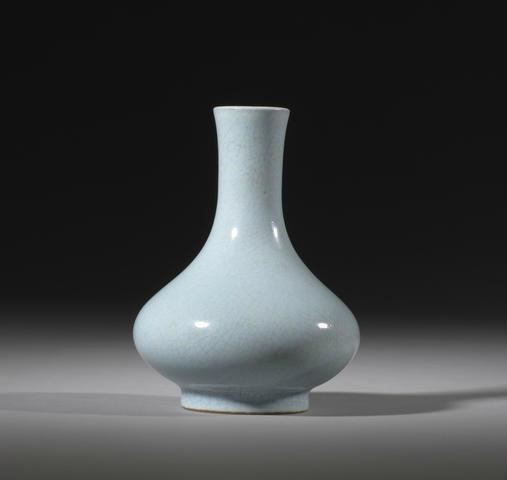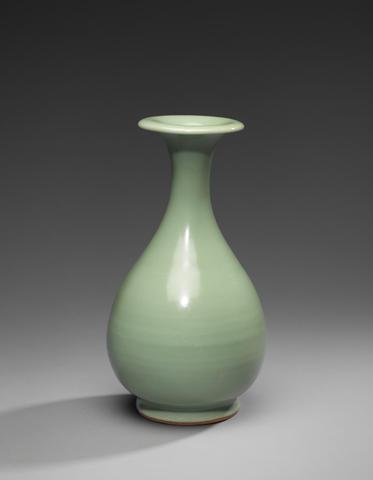The first image is the image on the left, the second image is the image on the right. For the images shown, is this caption "Each vase has a round pair shaped base with a skinny neck and a fluted opening at the top." true? Answer yes or no. No. 